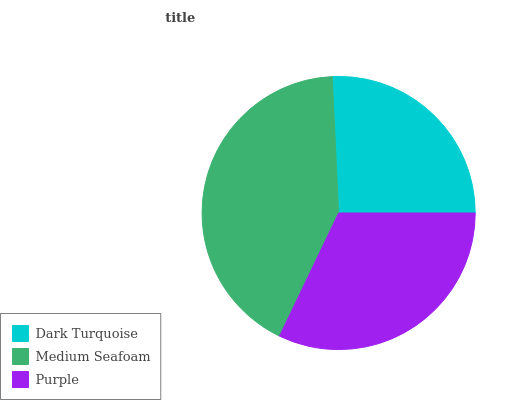Is Dark Turquoise the minimum?
Answer yes or no. Yes. Is Medium Seafoam the maximum?
Answer yes or no. Yes. Is Purple the minimum?
Answer yes or no. No. Is Purple the maximum?
Answer yes or no. No. Is Medium Seafoam greater than Purple?
Answer yes or no. Yes. Is Purple less than Medium Seafoam?
Answer yes or no. Yes. Is Purple greater than Medium Seafoam?
Answer yes or no. No. Is Medium Seafoam less than Purple?
Answer yes or no. No. Is Purple the high median?
Answer yes or no. Yes. Is Purple the low median?
Answer yes or no. Yes. Is Medium Seafoam the high median?
Answer yes or no. No. Is Medium Seafoam the low median?
Answer yes or no. No. 